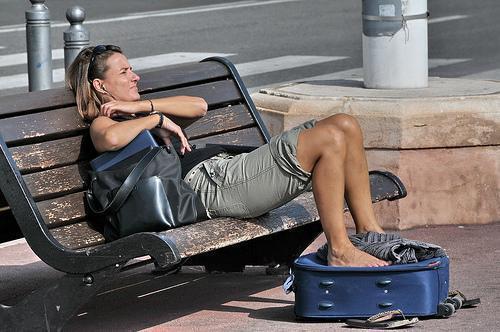How many black dogs are on the bed?
Give a very brief answer. 0. 